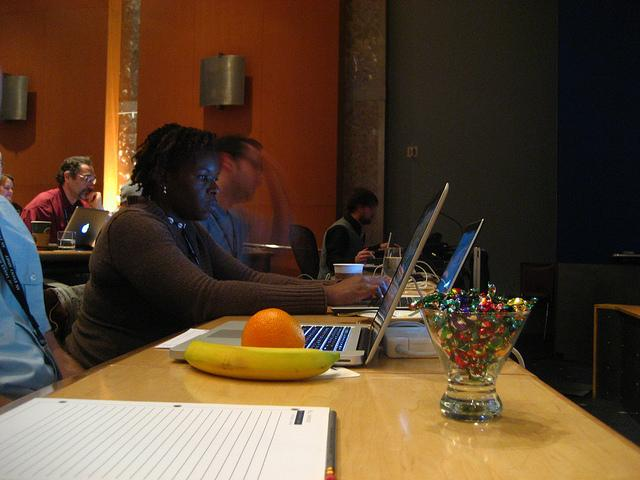Which food is the most unhealthy? Please explain your reasoning. candy. The candies are the most unhealthy food here. 